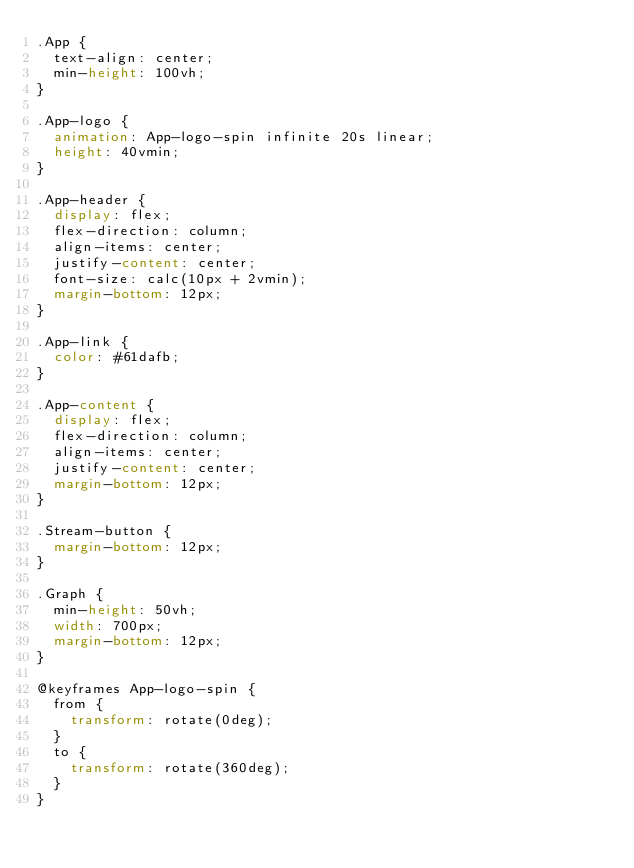<code> <loc_0><loc_0><loc_500><loc_500><_CSS_>.App {
  text-align: center;
  min-height: 100vh;
}

.App-logo {
  animation: App-logo-spin infinite 20s linear;
  height: 40vmin;
}

.App-header {
  display: flex;
  flex-direction: column;
  align-items: center;
  justify-content: center;
  font-size: calc(10px + 2vmin);
  margin-bottom: 12px;
}

.App-link {
  color: #61dafb;
}

.App-content {
  display: flex;
  flex-direction: column;
  align-items: center;
  justify-content: center;
  margin-bottom: 12px;
}

.Stream-button {
  margin-bottom: 12px;
}

.Graph {
  min-height: 50vh;
  width: 700px;
  margin-bottom: 12px;
}

@keyframes App-logo-spin {
  from {
    transform: rotate(0deg);
  }
  to {
    transform: rotate(360deg);
  }
}
</code> 